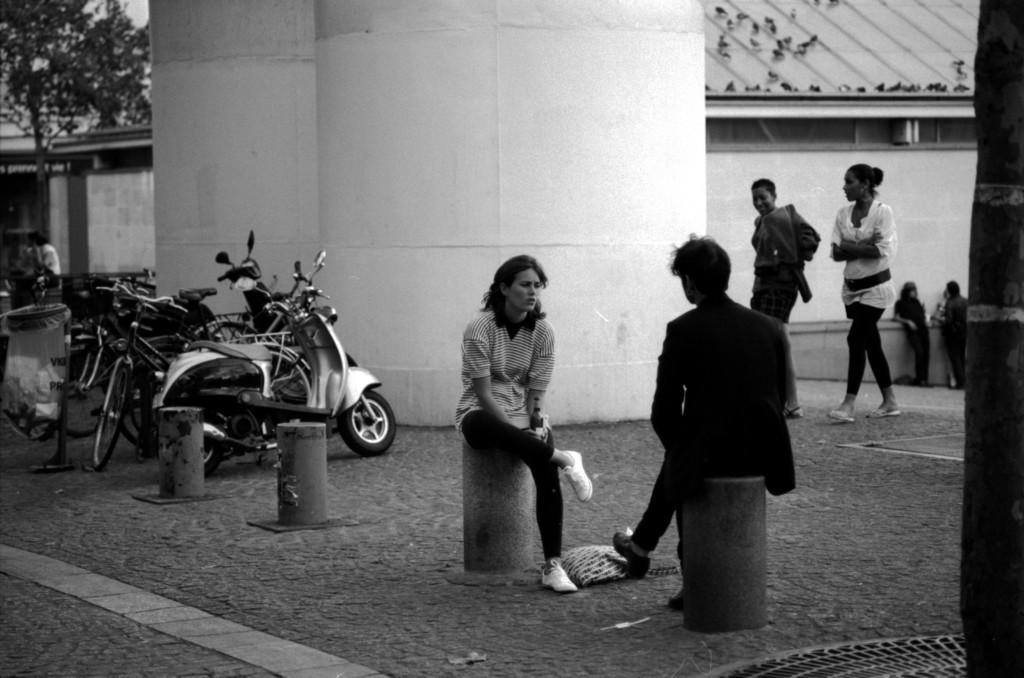Could you give a brief overview of what you see in this image? It is a black and white picture,on the footpath there are some vehicles parked beside a big pillar and in front of the pillar there are two people sitting on the cement walls and beside the big pillars there are some people walking on the footpath. In the background there is a tree. 